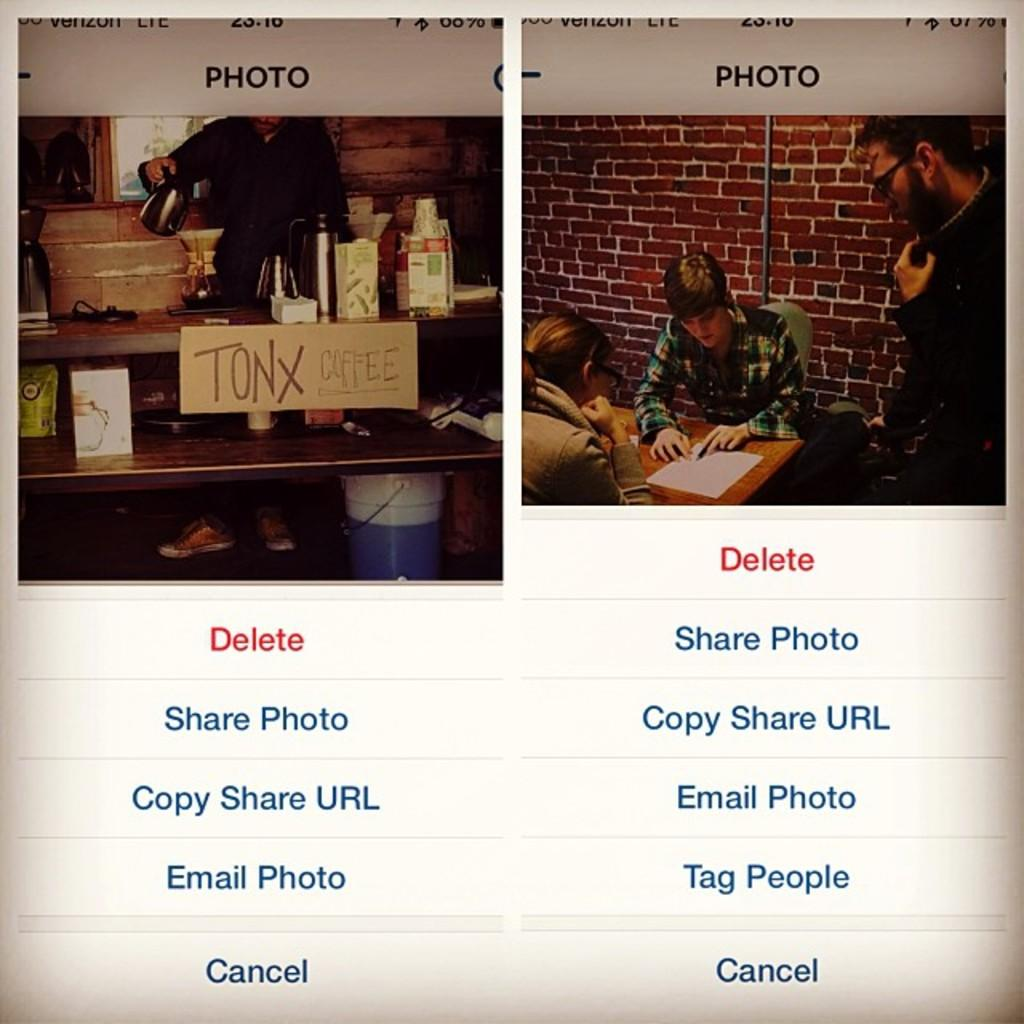<image>
Summarize the visual content of the image. Two phone screenshots of photos of the inside of a building where they serve Tonx Coffee. 